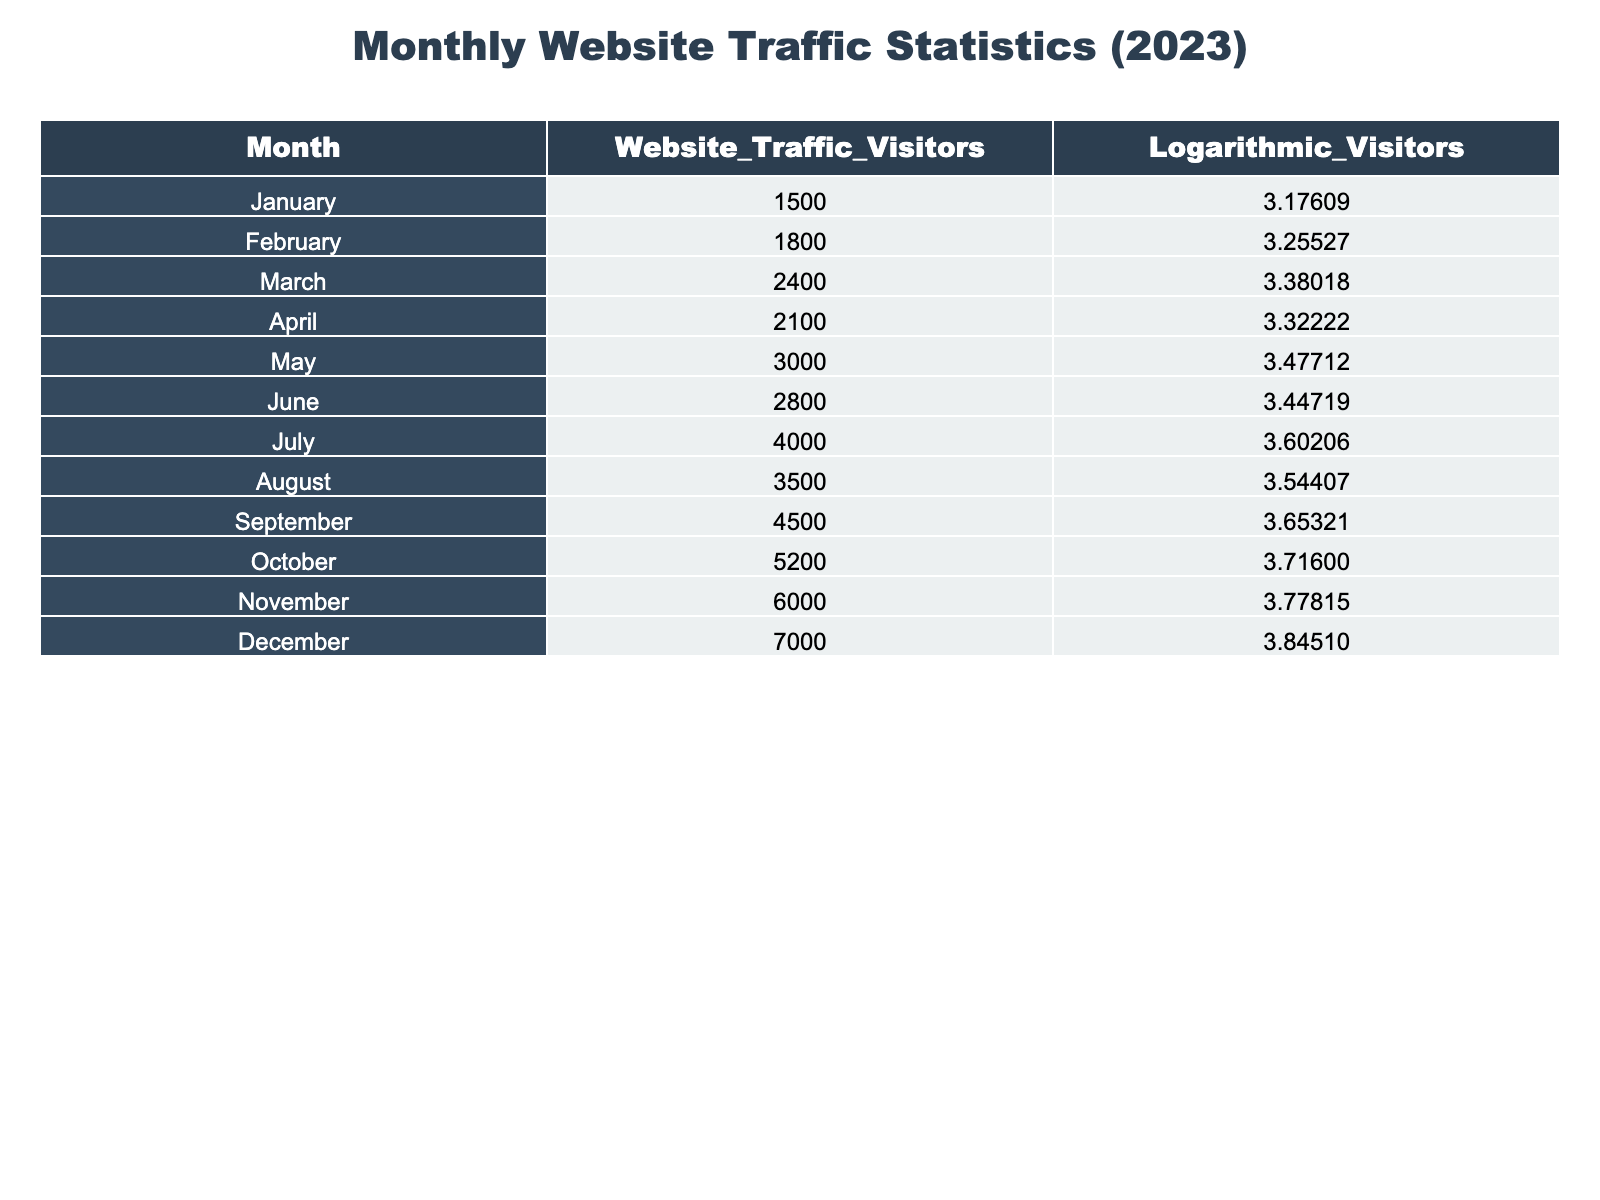What was the website traffic in March? The table clearly shows that the value for the website traffic visitors in March is listed as 2400.
Answer: 2400 What is the logarithmic value of visitors for the month of August? By looking directly at the table, we can see that the logarithmic value of visitors for August is 3.54407.
Answer: 3.54407 How many more visitors did the website receive in December compared to January? The number of visitors in December is 7000, and in January it is 1500. The difference is calculated as 7000 - 1500 = 5500.
Answer: 5500 What was the average monthly website traffic for the second half of the year (July to December)? The website traffic for the months from July to December are: 4000, 3500, 4500, 5200, 6000, and 7000. To find the average, we sum these values: 4000 + 3500 + 4500 + 5200 + 6000 + 7000 = 30200. Then, divide by the number of months (6): 30200 / 6 = 5033.33.
Answer: 5033.33 Did the website traffic in October exceed the average monthly traffic for the first half of the year (January to June)? The traffic for the first half of the year (January to June) can be summed: 1500 + 1800 + 2400 + 2100 + 3000 + 2800 = 13600 and the average is 13600 / 6 = 2266.67. Since October has 5200 visitors, which is greater than 2266.67, the statement is true.
Answer: Yes What was the maximum number of visitors in any month? The maximum number of visitors listed in the table is for December, with a value of 7000.
Answer: 7000 What was the percentage increase in visitors from March to May? In March, the visitors were 2400 and in May it increased to 3000. The increase is calculated as (3000 - 2400) / 2400 * 100 = 25%.
Answer: 25% How many months had more than 4000 visitors? By examining the table, we can count the months where the visitors exceeded 4000: July (4000), August (3500), September (4500), October (5200), November (6000), December (7000). The months with more than 4000 visitors are July, September, October, November, and December, totaling 5 months.
Answer: 5 